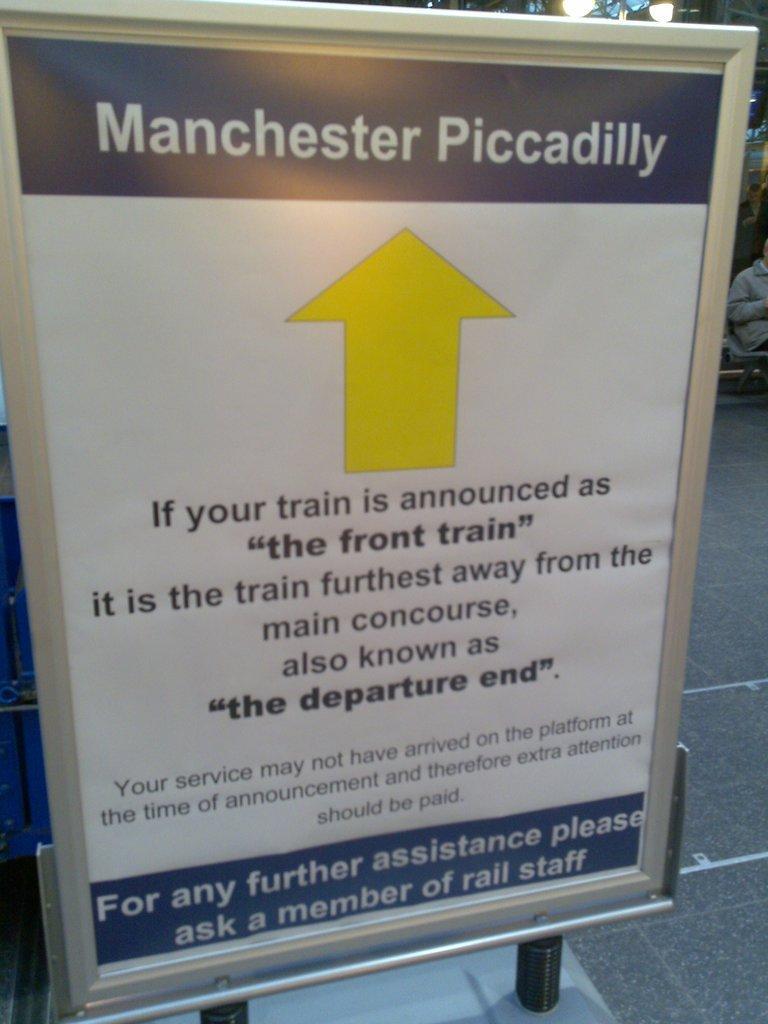Can you describe this image briefly? It is a notice board, showing an arrow mark which is in yellow color. 